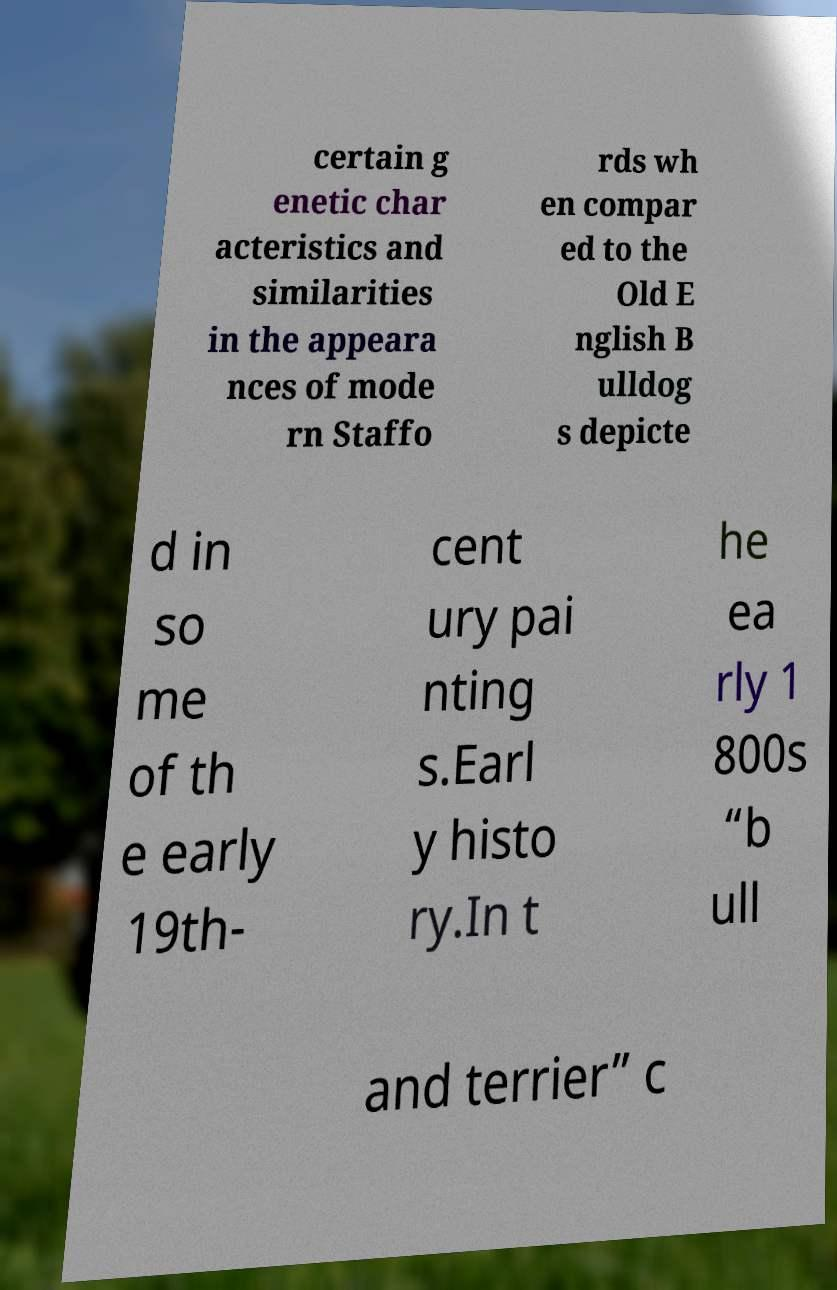What messages or text are displayed in this image? I need them in a readable, typed format. certain g enetic char acteristics and similarities in the appeara nces of mode rn Staffo rds wh en compar ed to the Old E nglish B ulldog s depicte d in so me of th e early 19th- cent ury pai nting s.Earl y histo ry.In t he ea rly 1 800s “b ull and terrier” c 